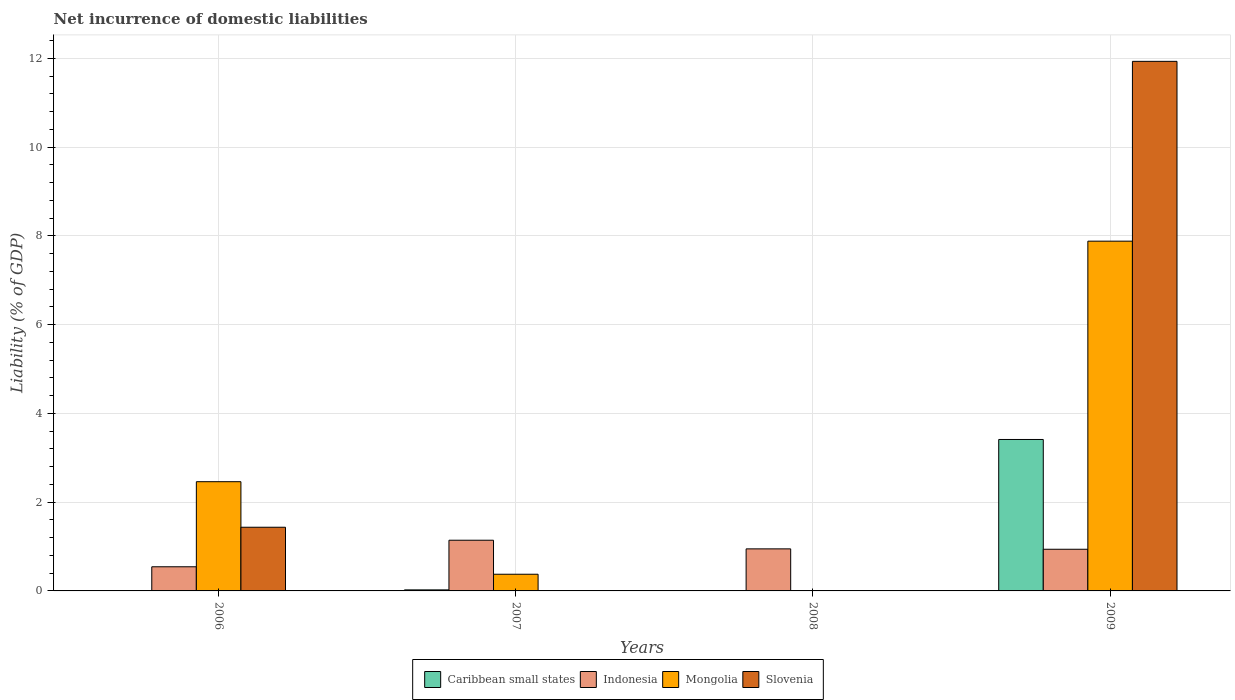How many different coloured bars are there?
Your answer should be very brief. 4. In how many cases, is the number of bars for a given year not equal to the number of legend labels?
Keep it short and to the point. 3. What is the net incurrence of domestic liabilities in Slovenia in 2006?
Provide a short and direct response. 1.43. Across all years, what is the maximum net incurrence of domestic liabilities in Slovenia?
Keep it short and to the point. 11.93. Across all years, what is the minimum net incurrence of domestic liabilities in Indonesia?
Give a very brief answer. 0.54. In which year was the net incurrence of domestic liabilities in Indonesia maximum?
Make the answer very short. 2007. What is the total net incurrence of domestic liabilities in Slovenia in the graph?
Provide a succinct answer. 13.37. What is the difference between the net incurrence of domestic liabilities in Indonesia in 2006 and that in 2008?
Give a very brief answer. -0.4. What is the difference between the net incurrence of domestic liabilities in Slovenia in 2007 and the net incurrence of domestic liabilities in Mongolia in 2009?
Offer a terse response. -7.88. What is the average net incurrence of domestic liabilities in Caribbean small states per year?
Offer a very short reply. 0.86. In the year 2009, what is the difference between the net incurrence of domestic liabilities in Indonesia and net incurrence of domestic liabilities in Caribbean small states?
Ensure brevity in your answer.  -2.47. In how many years, is the net incurrence of domestic liabilities in Caribbean small states greater than 1.6 %?
Keep it short and to the point. 1. What is the ratio of the net incurrence of domestic liabilities in Mongolia in 2006 to that in 2009?
Your answer should be very brief. 0.31. Is the net incurrence of domestic liabilities in Indonesia in 2006 less than that in 2007?
Keep it short and to the point. Yes. Is the difference between the net incurrence of domestic liabilities in Indonesia in 2007 and 2009 greater than the difference between the net incurrence of domestic liabilities in Caribbean small states in 2007 and 2009?
Provide a succinct answer. Yes. What is the difference between the highest and the second highest net incurrence of domestic liabilities in Indonesia?
Provide a succinct answer. 0.19. What is the difference between the highest and the lowest net incurrence of domestic liabilities in Indonesia?
Offer a very short reply. 0.6. Is the sum of the net incurrence of domestic liabilities in Caribbean small states in 2007 and 2009 greater than the maximum net incurrence of domestic liabilities in Slovenia across all years?
Provide a short and direct response. No. Is it the case that in every year, the sum of the net incurrence of domestic liabilities in Caribbean small states and net incurrence of domestic liabilities in Mongolia is greater than the sum of net incurrence of domestic liabilities in Indonesia and net incurrence of domestic liabilities in Slovenia?
Offer a very short reply. No. How many bars are there?
Provide a succinct answer. 11. What is the difference between two consecutive major ticks on the Y-axis?
Offer a very short reply. 2. Does the graph contain grids?
Provide a succinct answer. Yes. How many legend labels are there?
Offer a terse response. 4. How are the legend labels stacked?
Ensure brevity in your answer.  Horizontal. What is the title of the graph?
Keep it short and to the point. Net incurrence of domestic liabilities. Does "Sub-Saharan Africa (developing only)" appear as one of the legend labels in the graph?
Make the answer very short. No. What is the label or title of the X-axis?
Give a very brief answer. Years. What is the label or title of the Y-axis?
Make the answer very short. Liability (% of GDP). What is the Liability (% of GDP) in Indonesia in 2006?
Give a very brief answer. 0.54. What is the Liability (% of GDP) of Mongolia in 2006?
Make the answer very short. 2.46. What is the Liability (% of GDP) in Slovenia in 2006?
Provide a short and direct response. 1.43. What is the Liability (% of GDP) of Caribbean small states in 2007?
Your answer should be very brief. 0.02. What is the Liability (% of GDP) of Indonesia in 2007?
Offer a terse response. 1.14. What is the Liability (% of GDP) of Mongolia in 2007?
Provide a short and direct response. 0.38. What is the Liability (% of GDP) of Caribbean small states in 2008?
Your answer should be compact. 0. What is the Liability (% of GDP) in Indonesia in 2008?
Keep it short and to the point. 0.95. What is the Liability (% of GDP) in Caribbean small states in 2009?
Your answer should be very brief. 3.41. What is the Liability (% of GDP) of Indonesia in 2009?
Ensure brevity in your answer.  0.94. What is the Liability (% of GDP) in Mongolia in 2009?
Keep it short and to the point. 7.88. What is the Liability (% of GDP) in Slovenia in 2009?
Ensure brevity in your answer.  11.93. Across all years, what is the maximum Liability (% of GDP) of Caribbean small states?
Offer a terse response. 3.41. Across all years, what is the maximum Liability (% of GDP) of Indonesia?
Provide a succinct answer. 1.14. Across all years, what is the maximum Liability (% of GDP) in Mongolia?
Your answer should be compact. 7.88. Across all years, what is the maximum Liability (% of GDP) of Slovenia?
Provide a succinct answer. 11.93. Across all years, what is the minimum Liability (% of GDP) of Indonesia?
Make the answer very short. 0.54. Across all years, what is the minimum Liability (% of GDP) of Mongolia?
Offer a very short reply. 0. What is the total Liability (% of GDP) of Caribbean small states in the graph?
Your response must be concise. 3.44. What is the total Liability (% of GDP) of Indonesia in the graph?
Your answer should be compact. 3.57. What is the total Liability (% of GDP) in Mongolia in the graph?
Give a very brief answer. 10.72. What is the total Liability (% of GDP) in Slovenia in the graph?
Keep it short and to the point. 13.37. What is the difference between the Liability (% of GDP) in Indonesia in 2006 and that in 2007?
Ensure brevity in your answer.  -0.6. What is the difference between the Liability (% of GDP) of Mongolia in 2006 and that in 2007?
Provide a short and direct response. 2.08. What is the difference between the Liability (% of GDP) in Indonesia in 2006 and that in 2008?
Your answer should be very brief. -0.4. What is the difference between the Liability (% of GDP) of Indonesia in 2006 and that in 2009?
Your answer should be very brief. -0.39. What is the difference between the Liability (% of GDP) in Mongolia in 2006 and that in 2009?
Provide a short and direct response. -5.42. What is the difference between the Liability (% of GDP) of Slovenia in 2006 and that in 2009?
Ensure brevity in your answer.  -10.5. What is the difference between the Liability (% of GDP) of Indonesia in 2007 and that in 2008?
Ensure brevity in your answer.  0.19. What is the difference between the Liability (% of GDP) in Caribbean small states in 2007 and that in 2009?
Keep it short and to the point. -3.39. What is the difference between the Liability (% of GDP) of Indonesia in 2007 and that in 2009?
Offer a very short reply. 0.2. What is the difference between the Liability (% of GDP) in Mongolia in 2007 and that in 2009?
Offer a very short reply. -7.5. What is the difference between the Liability (% of GDP) of Indonesia in 2008 and that in 2009?
Ensure brevity in your answer.  0.01. What is the difference between the Liability (% of GDP) in Indonesia in 2006 and the Liability (% of GDP) in Mongolia in 2007?
Keep it short and to the point. 0.17. What is the difference between the Liability (% of GDP) in Indonesia in 2006 and the Liability (% of GDP) in Mongolia in 2009?
Your answer should be very brief. -7.34. What is the difference between the Liability (% of GDP) in Indonesia in 2006 and the Liability (% of GDP) in Slovenia in 2009?
Offer a terse response. -11.39. What is the difference between the Liability (% of GDP) of Mongolia in 2006 and the Liability (% of GDP) of Slovenia in 2009?
Provide a short and direct response. -9.47. What is the difference between the Liability (% of GDP) in Caribbean small states in 2007 and the Liability (% of GDP) in Indonesia in 2008?
Offer a terse response. -0.92. What is the difference between the Liability (% of GDP) in Caribbean small states in 2007 and the Liability (% of GDP) in Indonesia in 2009?
Offer a terse response. -0.92. What is the difference between the Liability (% of GDP) of Caribbean small states in 2007 and the Liability (% of GDP) of Mongolia in 2009?
Make the answer very short. -7.86. What is the difference between the Liability (% of GDP) in Caribbean small states in 2007 and the Liability (% of GDP) in Slovenia in 2009?
Offer a very short reply. -11.91. What is the difference between the Liability (% of GDP) in Indonesia in 2007 and the Liability (% of GDP) in Mongolia in 2009?
Make the answer very short. -6.74. What is the difference between the Liability (% of GDP) of Indonesia in 2007 and the Liability (% of GDP) of Slovenia in 2009?
Provide a succinct answer. -10.79. What is the difference between the Liability (% of GDP) of Mongolia in 2007 and the Liability (% of GDP) of Slovenia in 2009?
Give a very brief answer. -11.55. What is the difference between the Liability (% of GDP) in Indonesia in 2008 and the Liability (% of GDP) in Mongolia in 2009?
Your response must be concise. -6.93. What is the difference between the Liability (% of GDP) in Indonesia in 2008 and the Liability (% of GDP) in Slovenia in 2009?
Ensure brevity in your answer.  -10.98. What is the average Liability (% of GDP) of Caribbean small states per year?
Your answer should be compact. 0.86. What is the average Liability (% of GDP) in Indonesia per year?
Your answer should be compact. 0.89. What is the average Liability (% of GDP) of Mongolia per year?
Your answer should be very brief. 2.68. What is the average Liability (% of GDP) in Slovenia per year?
Your answer should be compact. 3.34. In the year 2006, what is the difference between the Liability (% of GDP) of Indonesia and Liability (% of GDP) of Mongolia?
Your answer should be very brief. -1.92. In the year 2006, what is the difference between the Liability (% of GDP) of Indonesia and Liability (% of GDP) of Slovenia?
Keep it short and to the point. -0.89. In the year 2007, what is the difference between the Liability (% of GDP) of Caribbean small states and Liability (% of GDP) of Indonesia?
Provide a succinct answer. -1.12. In the year 2007, what is the difference between the Liability (% of GDP) in Caribbean small states and Liability (% of GDP) in Mongolia?
Provide a succinct answer. -0.35. In the year 2007, what is the difference between the Liability (% of GDP) of Indonesia and Liability (% of GDP) of Mongolia?
Provide a succinct answer. 0.77. In the year 2009, what is the difference between the Liability (% of GDP) in Caribbean small states and Liability (% of GDP) in Indonesia?
Keep it short and to the point. 2.47. In the year 2009, what is the difference between the Liability (% of GDP) in Caribbean small states and Liability (% of GDP) in Mongolia?
Provide a short and direct response. -4.47. In the year 2009, what is the difference between the Liability (% of GDP) in Caribbean small states and Liability (% of GDP) in Slovenia?
Provide a short and direct response. -8.52. In the year 2009, what is the difference between the Liability (% of GDP) in Indonesia and Liability (% of GDP) in Mongolia?
Your response must be concise. -6.94. In the year 2009, what is the difference between the Liability (% of GDP) of Indonesia and Liability (% of GDP) of Slovenia?
Offer a terse response. -10.99. In the year 2009, what is the difference between the Liability (% of GDP) in Mongolia and Liability (% of GDP) in Slovenia?
Ensure brevity in your answer.  -4.05. What is the ratio of the Liability (% of GDP) in Indonesia in 2006 to that in 2007?
Provide a short and direct response. 0.48. What is the ratio of the Liability (% of GDP) in Mongolia in 2006 to that in 2007?
Your response must be concise. 6.55. What is the ratio of the Liability (% of GDP) in Indonesia in 2006 to that in 2008?
Give a very brief answer. 0.57. What is the ratio of the Liability (% of GDP) of Indonesia in 2006 to that in 2009?
Your answer should be compact. 0.58. What is the ratio of the Liability (% of GDP) of Mongolia in 2006 to that in 2009?
Provide a succinct answer. 0.31. What is the ratio of the Liability (% of GDP) of Slovenia in 2006 to that in 2009?
Your answer should be compact. 0.12. What is the ratio of the Liability (% of GDP) in Indonesia in 2007 to that in 2008?
Your answer should be compact. 1.21. What is the ratio of the Liability (% of GDP) in Caribbean small states in 2007 to that in 2009?
Provide a succinct answer. 0.01. What is the ratio of the Liability (% of GDP) of Indonesia in 2007 to that in 2009?
Offer a terse response. 1.22. What is the ratio of the Liability (% of GDP) in Mongolia in 2007 to that in 2009?
Provide a succinct answer. 0.05. What is the ratio of the Liability (% of GDP) of Indonesia in 2008 to that in 2009?
Make the answer very short. 1.01. What is the difference between the highest and the second highest Liability (% of GDP) in Indonesia?
Provide a succinct answer. 0.19. What is the difference between the highest and the second highest Liability (% of GDP) in Mongolia?
Offer a terse response. 5.42. What is the difference between the highest and the lowest Liability (% of GDP) in Caribbean small states?
Offer a terse response. 3.41. What is the difference between the highest and the lowest Liability (% of GDP) of Indonesia?
Give a very brief answer. 0.6. What is the difference between the highest and the lowest Liability (% of GDP) of Mongolia?
Provide a succinct answer. 7.88. What is the difference between the highest and the lowest Liability (% of GDP) in Slovenia?
Your answer should be very brief. 11.93. 